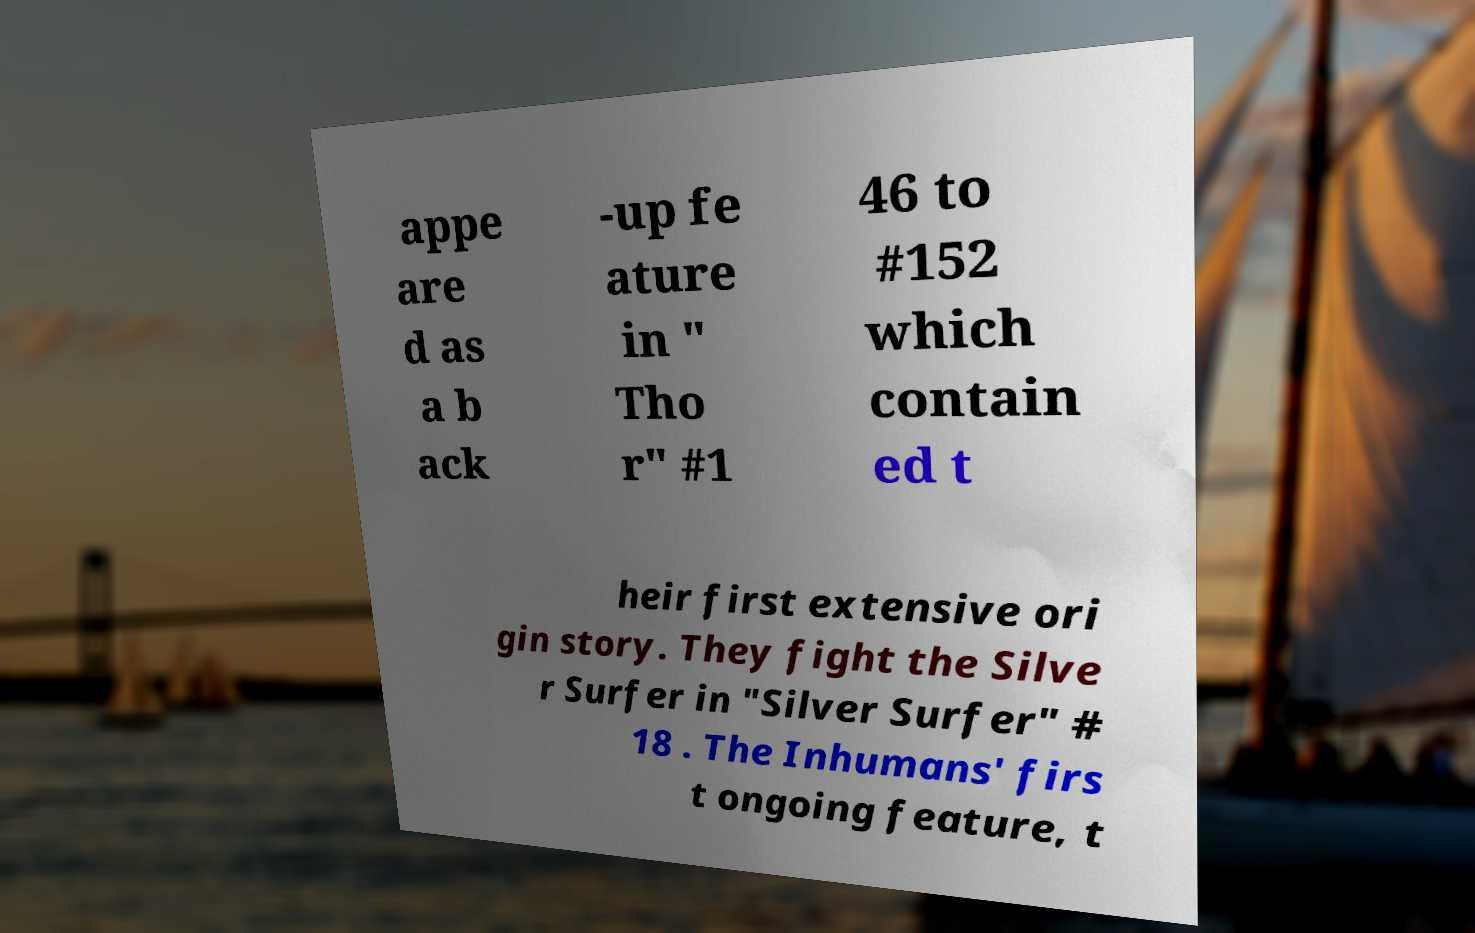I need the written content from this picture converted into text. Can you do that? appe are d as a b ack -up fe ature in " Tho r" #1 46 to #152 which contain ed t heir first extensive ori gin story. They fight the Silve r Surfer in "Silver Surfer" # 18 . The Inhumans' firs t ongoing feature, t 